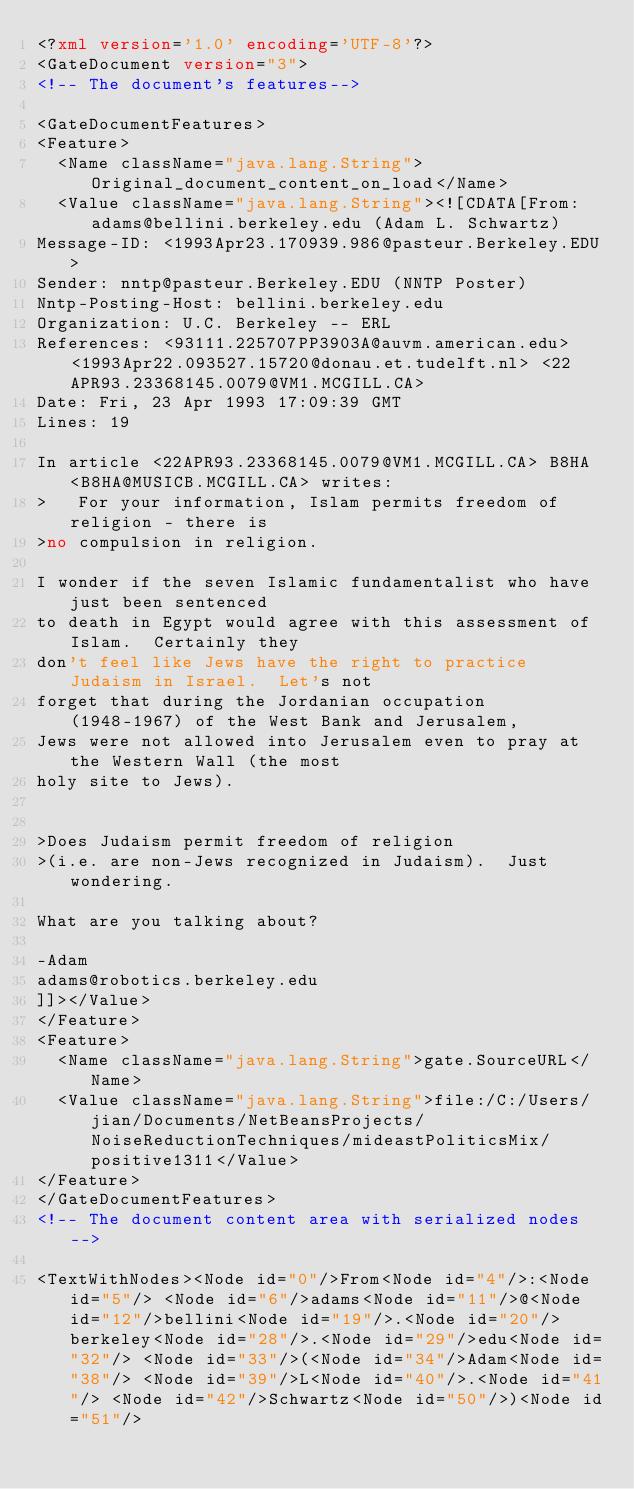<code> <loc_0><loc_0><loc_500><loc_500><_XML_><?xml version='1.0' encoding='UTF-8'?>
<GateDocument version="3">
<!-- The document's features-->

<GateDocumentFeatures>
<Feature>
  <Name className="java.lang.String">Original_document_content_on_load</Name>
  <Value className="java.lang.String"><![CDATA[From: adams@bellini.berkeley.edu (Adam L. Schwartz)
Message-ID: <1993Apr23.170939.986@pasteur.Berkeley.EDU>
Sender: nntp@pasteur.Berkeley.EDU (NNTP Poster)
Nntp-Posting-Host: bellini.berkeley.edu
Organization: U.C. Berkeley -- ERL
References: <93111.225707PP3903A@auvm.american.edu> <1993Apr22.093527.15720@donau.et.tudelft.nl> <22APR93.23368145.0079@VM1.MCGILL.CA>
Date: Fri, 23 Apr 1993 17:09:39 GMT
Lines: 19

In article <22APR93.23368145.0079@VM1.MCGILL.CA> B8HA <B8HA@MUSICB.MCGILL.CA> writes:
>   For your information, Islam permits freedom of religion - there is
>no compulsion in religion.  

I wonder if the seven Islamic fundamentalist who have just been sentenced
to death in Egypt would agree with this assessment of Islam.  Certainly they
don't feel like Jews have the right to practice Judaism in Israel.  Let's not
forget that during the Jordanian occupation (1948-1967) of the West Bank and Jerusalem,
Jews were not allowed into Jerusalem even to pray at the Western Wall (the most
holy site to Jews).


>Does Judaism permit freedom of religion
>(i.e. are non-Jews recognized in Judaism).  Just wondering.

What are you talking about?  

-Adam
adams@robotics.berkeley.edu
]]></Value>
</Feature>
<Feature>
  <Name className="java.lang.String">gate.SourceURL</Name>
  <Value className="java.lang.String">file:/C:/Users/jian/Documents/NetBeansProjects/NoiseReductionTechniques/mideastPoliticsMix/positive1311</Value>
</Feature>
</GateDocumentFeatures>
<!-- The document content area with serialized nodes -->

<TextWithNodes><Node id="0"/>From<Node id="4"/>:<Node id="5"/> <Node id="6"/>adams<Node id="11"/>@<Node id="12"/>bellini<Node id="19"/>.<Node id="20"/>berkeley<Node id="28"/>.<Node id="29"/>edu<Node id="32"/> <Node id="33"/>(<Node id="34"/>Adam<Node id="38"/> <Node id="39"/>L<Node id="40"/>.<Node id="41"/> <Node id="42"/>Schwartz<Node id="50"/>)<Node id="51"/></code> 